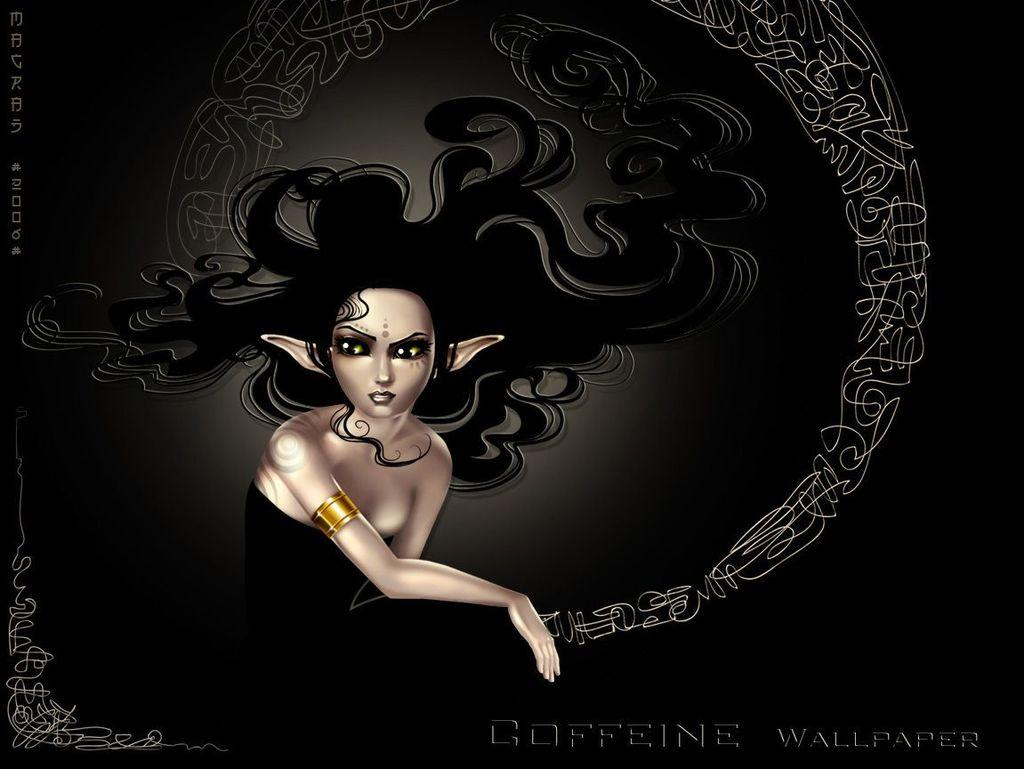What type of image is being described? The image is animated. Can you describe the character in the image? There is a woman in the image. What is the woman wearing? The woman is wearing a black dress. What color crayon is the woman using to draw in the image? There is no crayon or drawing activity present in the image; it features an animated woman wearing a black dress. 